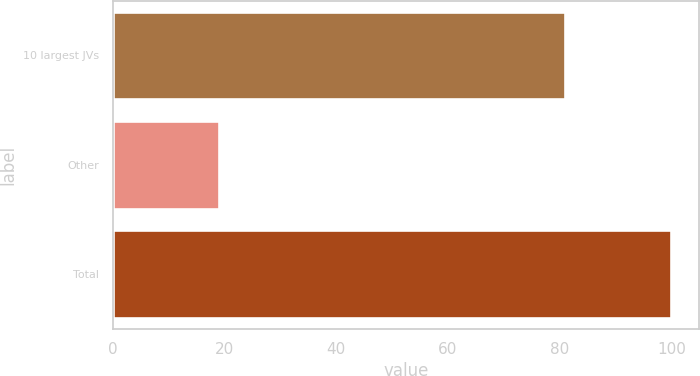<chart> <loc_0><loc_0><loc_500><loc_500><bar_chart><fcel>10 largest JVs<fcel>Other<fcel>Total<nl><fcel>81<fcel>19<fcel>100<nl></chart> 